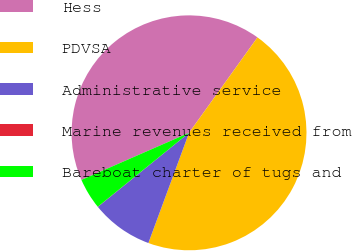Convert chart to OTSL. <chart><loc_0><loc_0><loc_500><loc_500><pie_chart><fcel>Hess<fcel>PDVSA<fcel>Administrative service<fcel>Marine revenues received from<fcel>Bareboat charter of tugs and<nl><fcel>41.47%<fcel>45.72%<fcel>8.52%<fcel>0.02%<fcel>4.27%<nl></chart> 